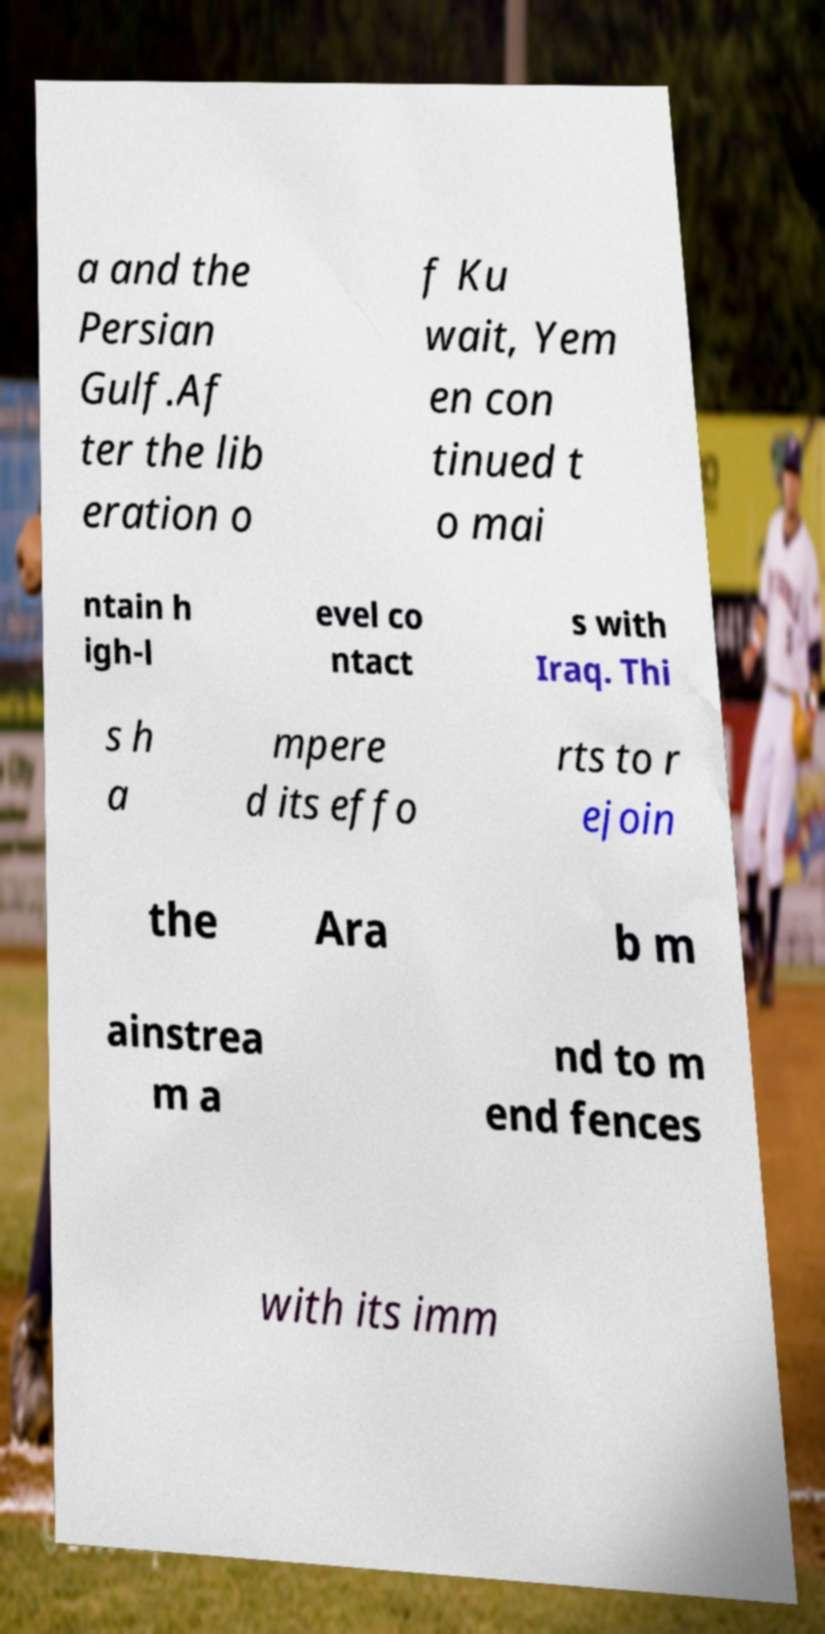What messages or text are displayed in this image? I need them in a readable, typed format. a and the Persian Gulf.Af ter the lib eration o f Ku wait, Yem en con tinued t o mai ntain h igh-l evel co ntact s with Iraq. Thi s h a mpere d its effo rts to r ejoin the Ara b m ainstrea m a nd to m end fences with its imm 